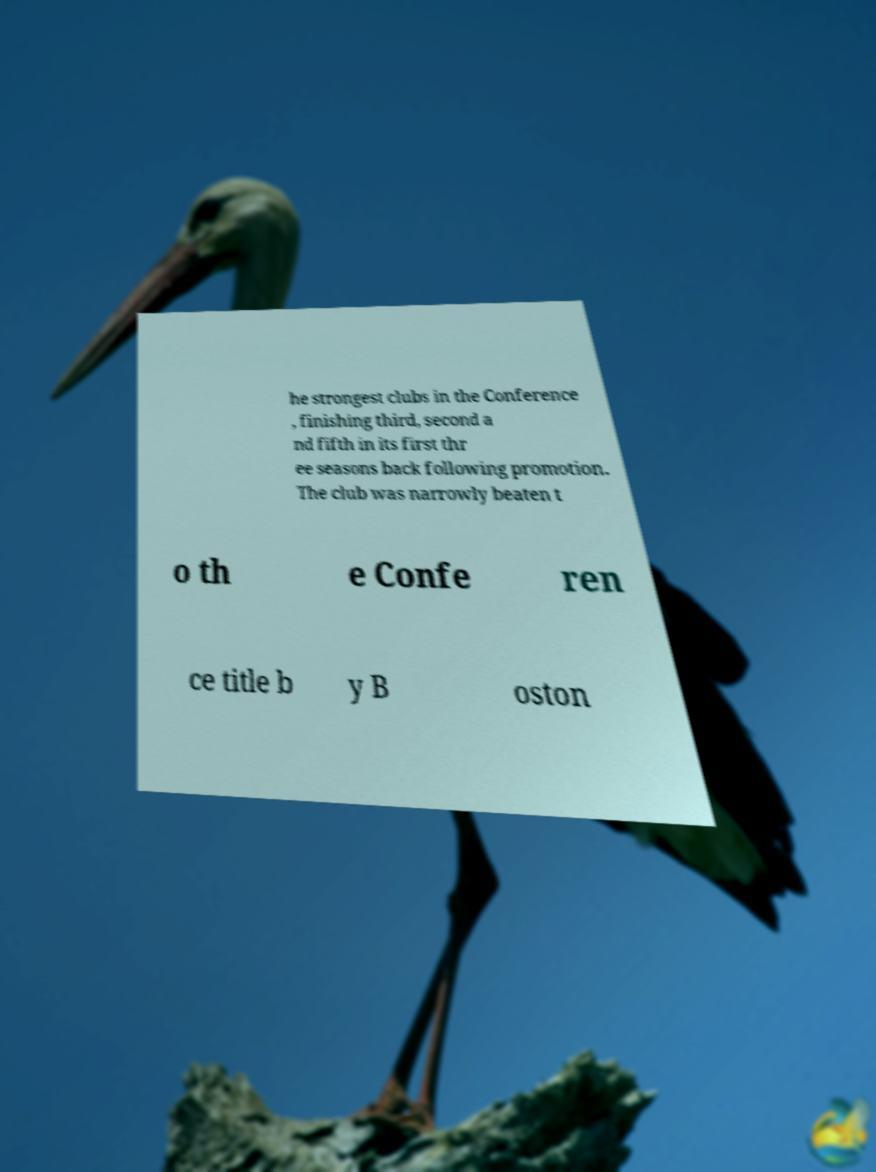What messages or text are displayed in this image? I need them in a readable, typed format. he strongest clubs in the Conference , finishing third, second a nd fifth in its first thr ee seasons back following promotion. The club was narrowly beaten t o th e Confe ren ce title b y B oston 